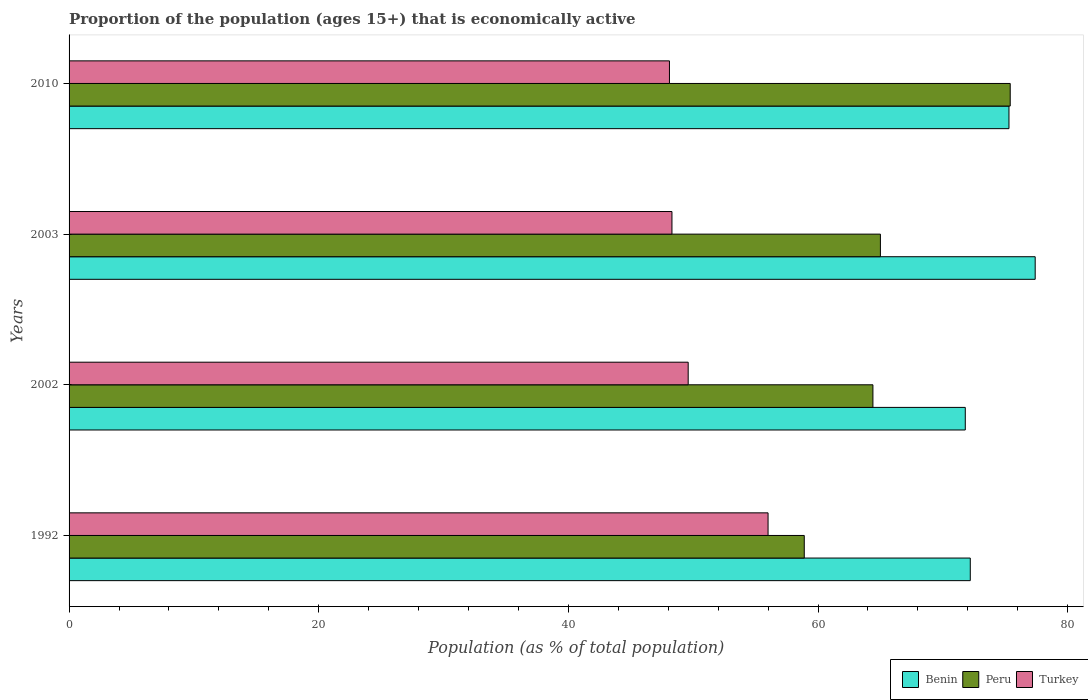How many different coloured bars are there?
Keep it short and to the point. 3. How many groups of bars are there?
Provide a short and direct response. 4. Are the number of bars per tick equal to the number of legend labels?
Keep it short and to the point. Yes. What is the proportion of the population that is economically active in Peru in 2002?
Offer a terse response. 64.4. Across all years, what is the maximum proportion of the population that is economically active in Benin?
Make the answer very short. 77.4. Across all years, what is the minimum proportion of the population that is economically active in Turkey?
Ensure brevity in your answer.  48.1. In which year was the proportion of the population that is economically active in Benin maximum?
Make the answer very short. 2003. In which year was the proportion of the population that is economically active in Turkey minimum?
Your answer should be very brief. 2010. What is the total proportion of the population that is economically active in Peru in the graph?
Keep it short and to the point. 263.7. What is the difference between the proportion of the population that is economically active in Turkey in 2003 and that in 2010?
Offer a very short reply. 0.2. What is the difference between the proportion of the population that is economically active in Turkey in 1992 and the proportion of the population that is economically active in Benin in 2003?
Provide a short and direct response. -21.4. What is the average proportion of the population that is economically active in Benin per year?
Make the answer very short. 74.18. In the year 2002, what is the difference between the proportion of the population that is economically active in Turkey and proportion of the population that is economically active in Peru?
Ensure brevity in your answer.  -14.8. In how many years, is the proportion of the population that is economically active in Peru greater than 20 %?
Offer a terse response. 4. What is the ratio of the proportion of the population that is economically active in Turkey in 1992 to that in 2002?
Ensure brevity in your answer.  1.13. Is the difference between the proportion of the population that is economically active in Turkey in 2002 and 2010 greater than the difference between the proportion of the population that is economically active in Peru in 2002 and 2010?
Offer a terse response. Yes. What is the difference between the highest and the second highest proportion of the population that is economically active in Peru?
Keep it short and to the point. 10.4. What is the difference between the highest and the lowest proportion of the population that is economically active in Peru?
Your response must be concise. 16.5. Is the sum of the proportion of the population that is economically active in Benin in 1992 and 2003 greater than the maximum proportion of the population that is economically active in Turkey across all years?
Your response must be concise. Yes. Is it the case that in every year, the sum of the proportion of the population that is economically active in Turkey and proportion of the population that is economically active in Benin is greater than the proportion of the population that is economically active in Peru?
Provide a short and direct response. Yes. Are all the bars in the graph horizontal?
Make the answer very short. Yes. What is the difference between two consecutive major ticks on the X-axis?
Ensure brevity in your answer.  20. Are the values on the major ticks of X-axis written in scientific E-notation?
Your answer should be very brief. No. Does the graph contain any zero values?
Offer a very short reply. No. Does the graph contain grids?
Offer a very short reply. No. Where does the legend appear in the graph?
Offer a terse response. Bottom right. How many legend labels are there?
Offer a terse response. 3. How are the legend labels stacked?
Keep it short and to the point. Horizontal. What is the title of the graph?
Offer a terse response. Proportion of the population (ages 15+) that is economically active. Does "Middle East & North Africa (all income levels)" appear as one of the legend labels in the graph?
Provide a short and direct response. No. What is the label or title of the X-axis?
Keep it short and to the point. Population (as % of total population). What is the Population (as % of total population) in Benin in 1992?
Provide a succinct answer. 72.2. What is the Population (as % of total population) of Peru in 1992?
Offer a very short reply. 58.9. What is the Population (as % of total population) of Turkey in 1992?
Your answer should be compact. 56. What is the Population (as % of total population) of Benin in 2002?
Your answer should be compact. 71.8. What is the Population (as % of total population) in Peru in 2002?
Make the answer very short. 64.4. What is the Population (as % of total population) in Turkey in 2002?
Your answer should be very brief. 49.6. What is the Population (as % of total population) of Benin in 2003?
Offer a terse response. 77.4. What is the Population (as % of total population) of Peru in 2003?
Make the answer very short. 65. What is the Population (as % of total population) of Turkey in 2003?
Your answer should be very brief. 48.3. What is the Population (as % of total population) in Benin in 2010?
Keep it short and to the point. 75.3. What is the Population (as % of total population) in Peru in 2010?
Your answer should be compact. 75.4. What is the Population (as % of total population) of Turkey in 2010?
Provide a short and direct response. 48.1. Across all years, what is the maximum Population (as % of total population) in Benin?
Your answer should be compact. 77.4. Across all years, what is the maximum Population (as % of total population) in Peru?
Your answer should be compact. 75.4. Across all years, what is the minimum Population (as % of total population) of Benin?
Your answer should be very brief. 71.8. Across all years, what is the minimum Population (as % of total population) in Peru?
Give a very brief answer. 58.9. Across all years, what is the minimum Population (as % of total population) in Turkey?
Your response must be concise. 48.1. What is the total Population (as % of total population) in Benin in the graph?
Provide a succinct answer. 296.7. What is the total Population (as % of total population) in Peru in the graph?
Offer a very short reply. 263.7. What is the total Population (as % of total population) of Turkey in the graph?
Provide a succinct answer. 202. What is the difference between the Population (as % of total population) in Turkey in 1992 and that in 2002?
Your answer should be very brief. 6.4. What is the difference between the Population (as % of total population) in Peru in 1992 and that in 2003?
Give a very brief answer. -6.1. What is the difference between the Population (as % of total population) in Peru in 1992 and that in 2010?
Provide a succinct answer. -16.5. What is the difference between the Population (as % of total population) in Benin in 2002 and that in 2010?
Provide a succinct answer. -3.5. What is the difference between the Population (as % of total population) of Peru in 2003 and that in 2010?
Your answer should be compact. -10.4. What is the difference between the Population (as % of total population) of Benin in 1992 and the Population (as % of total population) of Peru in 2002?
Your response must be concise. 7.8. What is the difference between the Population (as % of total population) in Benin in 1992 and the Population (as % of total population) in Turkey in 2002?
Make the answer very short. 22.6. What is the difference between the Population (as % of total population) of Benin in 1992 and the Population (as % of total population) of Turkey in 2003?
Offer a terse response. 23.9. What is the difference between the Population (as % of total population) of Benin in 1992 and the Population (as % of total population) of Peru in 2010?
Offer a terse response. -3.2. What is the difference between the Population (as % of total population) of Benin in 1992 and the Population (as % of total population) of Turkey in 2010?
Provide a short and direct response. 24.1. What is the difference between the Population (as % of total population) in Peru in 1992 and the Population (as % of total population) in Turkey in 2010?
Make the answer very short. 10.8. What is the difference between the Population (as % of total population) of Benin in 2002 and the Population (as % of total population) of Peru in 2010?
Offer a very short reply. -3.6. What is the difference between the Population (as % of total population) in Benin in 2002 and the Population (as % of total population) in Turkey in 2010?
Offer a terse response. 23.7. What is the difference between the Population (as % of total population) of Peru in 2002 and the Population (as % of total population) of Turkey in 2010?
Provide a succinct answer. 16.3. What is the difference between the Population (as % of total population) of Benin in 2003 and the Population (as % of total population) of Peru in 2010?
Provide a succinct answer. 2. What is the difference between the Population (as % of total population) in Benin in 2003 and the Population (as % of total population) in Turkey in 2010?
Ensure brevity in your answer.  29.3. What is the difference between the Population (as % of total population) in Peru in 2003 and the Population (as % of total population) in Turkey in 2010?
Make the answer very short. 16.9. What is the average Population (as % of total population) of Benin per year?
Offer a terse response. 74.17. What is the average Population (as % of total population) in Peru per year?
Provide a short and direct response. 65.92. What is the average Population (as % of total population) in Turkey per year?
Ensure brevity in your answer.  50.5. In the year 1992, what is the difference between the Population (as % of total population) of Benin and Population (as % of total population) of Peru?
Offer a terse response. 13.3. In the year 1992, what is the difference between the Population (as % of total population) of Benin and Population (as % of total population) of Turkey?
Keep it short and to the point. 16.2. In the year 2002, what is the difference between the Population (as % of total population) in Benin and Population (as % of total population) in Peru?
Keep it short and to the point. 7.4. In the year 2002, what is the difference between the Population (as % of total population) in Benin and Population (as % of total population) in Turkey?
Ensure brevity in your answer.  22.2. In the year 2002, what is the difference between the Population (as % of total population) of Peru and Population (as % of total population) of Turkey?
Offer a very short reply. 14.8. In the year 2003, what is the difference between the Population (as % of total population) of Benin and Population (as % of total population) of Peru?
Offer a very short reply. 12.4. In the year 2003, what is the difference between the Population (as % of total population) in Benin and Population (as % of total population) in Turkey?
Provide a short and direct response. 29.1. In the year 2010, what is the difference between the Population (as % of total population) of Benin and Population (as % of total population) of Peru?
Ensure brevity in your answer.  -0.1. In the year 2010, what is the difference between the Population (as % of total population) in Benin and Population (as % of total population) in Turkey?
Ensure brevity in your answer.  27.2. In the year 2010, what is the difference between the Population (as % of total population) of Peru and Population (as % of total population) of Turkey?
Provide a succinct answer. 27.3. What is the ratio of the Population (as % of total population) in Benin in 1992 to that in 2002?
Your response must be concise. 1.01. What is the ratio of the Population (as % of total population) of Peru in 1992 to that in 2002?
Give a very brief answer. 0.91. What is the ratio of the Population (as % of total population) in Turkey in 1992 to that in 2002?
Provide a short and direct response. 1.13. What is the ratio of the Population (as % of total population) in Benin in 1992 to that in 2003?
Offer a terse response. 0.93. What is the ratio of the Population (as % of total population) of Peru in 1992 to that in 2003?
Ensure brevity in your answer.  0.91. What is the ratio of the Population (as % of total population) in Turkey in 1992 to that in 2003?
Provide a short and direct response. 1.16. What is the ratio of the Population (as % of total population) of Benin in 1992 to that in 2010?
Your answer should be compact. 0.96. What is the ratio of the Population (as % of total population) in Peru in 1992 to that in 2010?
Your answer should be very brief. 0.78. What is the ratio of the Population (as % of total population) of Turkey in 1992 to that in 2010?
Offer a very short reply. 1.16. What is the ratio of the Population (as % of total population) of Benin in 2002 to that in 2003?
Your answer should be compact. 0.93. What is the ratio of the Population (as % of total population) in Peru in 2002 to that in 2003?
Offer a terse response. 0.99. What is the ratio of the Population (as % of total population) of Turkey in 2002 to that in 2003?
Your answer should be very brief. 1.03. What is the ratio of the Population (as % of total population) in Benin in 2002 to that in 2010?
Make the answer very short. 0.95. What is the ratio of the Population (as % of total population) of Peru in 2002 to that in 2010?
Keep it short and to the point. 0.85. What is the ratio of the Population (as % of total population) of Turkey in 2002 to that in 2010?
Your answer should be very brief. 1.03. What is the ratio of the Population (as % of total population) in Benin in 2003 to that in 2010?
Your answer should be compact. 1.03. What is the ratio of the Population (as % of total population) in Peru in 2003 to that in 2010?
Ensure brevity in your answer.  0.86. What is the ratio of the Population (as % of total population) of Turkey in 2003 to that in 2010?
Your answer should be very brief. 1. What is the difference between the highest and the second highest Population (as % of total population) of Benin?
Your answer should be compact. 2.1. What is the difference between the highest and the second highest Population (as % of total population) in Peru?
Your response must be concise. 10.4. What is the difference between the highest and the lowest Population (as % of total population) in Benin?
Give a very brief answer. 5.6. What is the difference between the highest and the lowest Population (as % of total population) in Turkey?
Offer a very short reply. 7.9. 